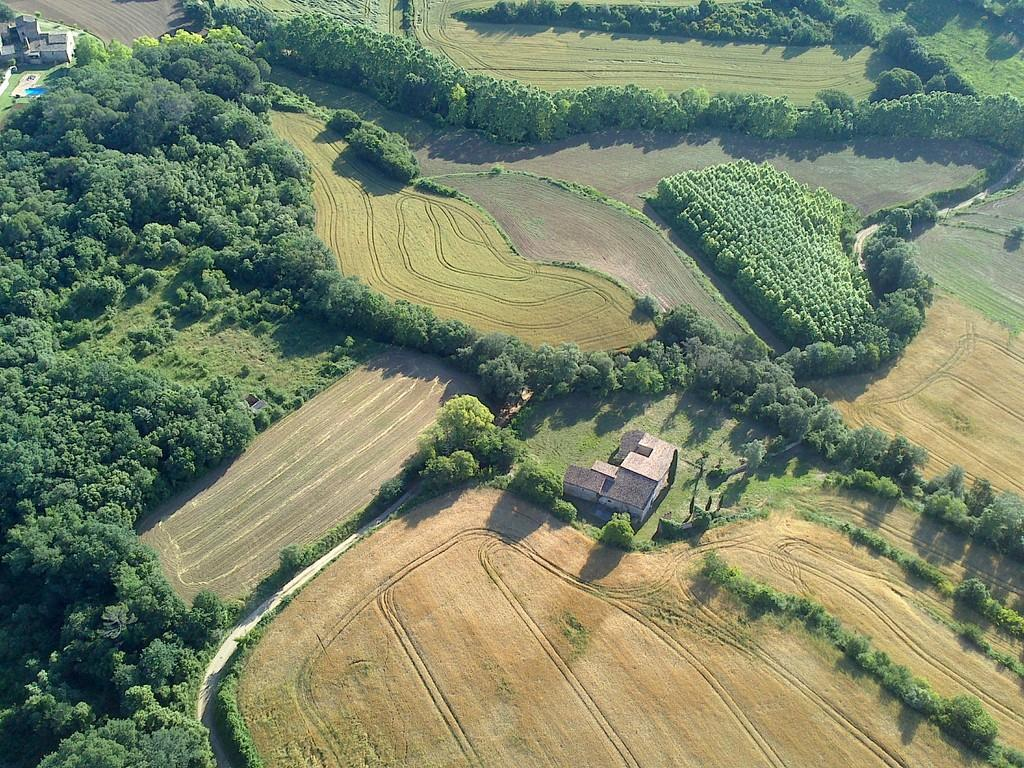What type of vegetation is visible in the image? There is grass in the image. What structures can be seen on the ground in the image? There are sheds on the ground in the image. What other natural elements are present in the image? Trees are present in the image. What type of berry is growing on the trees in the image? There is no mention of berries or any specific type of fruit growing on the trees in the image. 